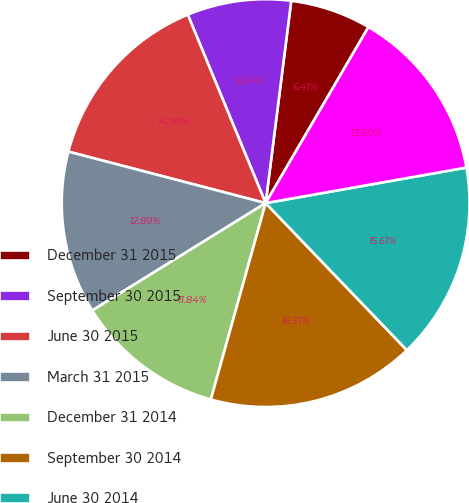Convert chart to OTSL. <chart><loc_0><loc_0><loc_500><loc_500><pie_chart><fcel>December 31 2015<fcel>September 30 2015<fcel>June 30 2015<fcel>March 31 2015<fcel>December 31 2014<fcel>September 30 2014<fcel>June 30 2014<fcel>March 31 2014<nl><fcel>6.41%<fcel>8.24%<fcel>14.7%<fcel>12.89%<fcel>11.84%<fcel>16.51%<fcel>15.61%<fcel>13.8%<nl></chart> 